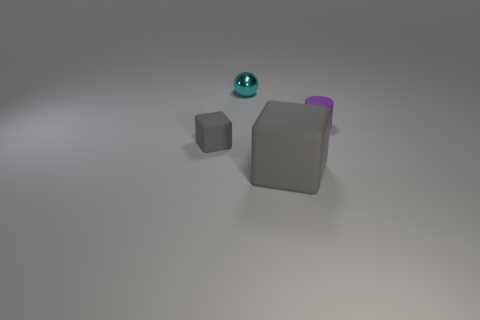Add 2 tiny balls. How many objects exist? 6 Subtract all balls. How many objects are left? 3 Add 4 small blue rubber cylinders. How many small blue rubber cylinders exist? 4 Subtract 0 red cylinders. How many objects are left? 4 Subtract all shiny things. Subtract all gray matte objects. How many objects are left? 1 Add 2 tiny purple matte objects. How many tiny purple matte objects are left? 3 